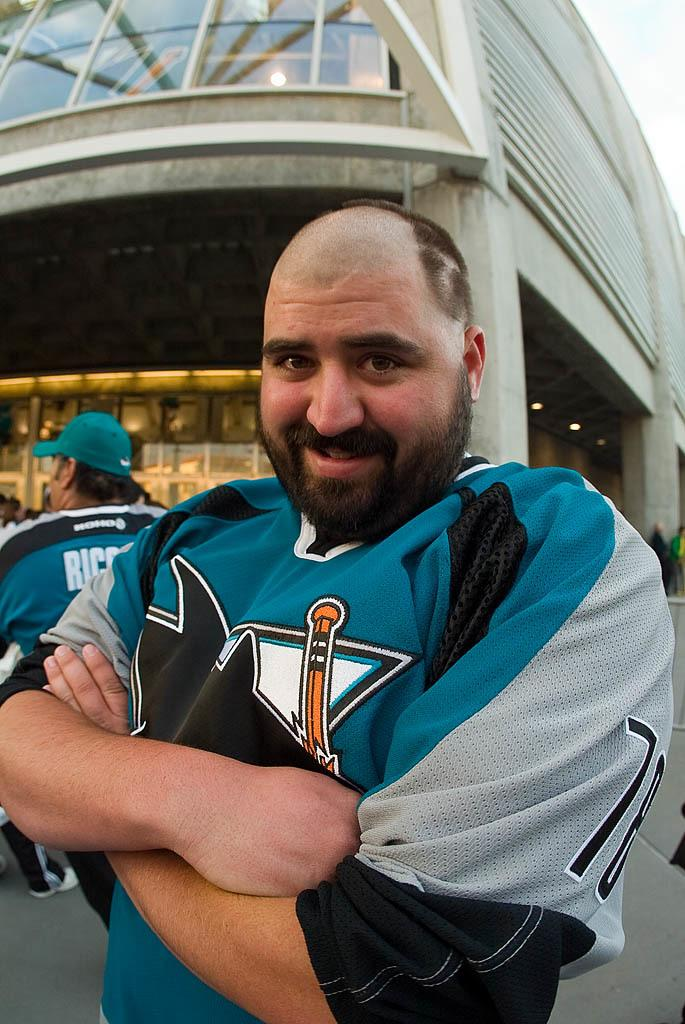<image>
Give a short and clear explanation of the subsequent image. A man looking happy to wearing his game jersey with the number 78 on the sleeve. 